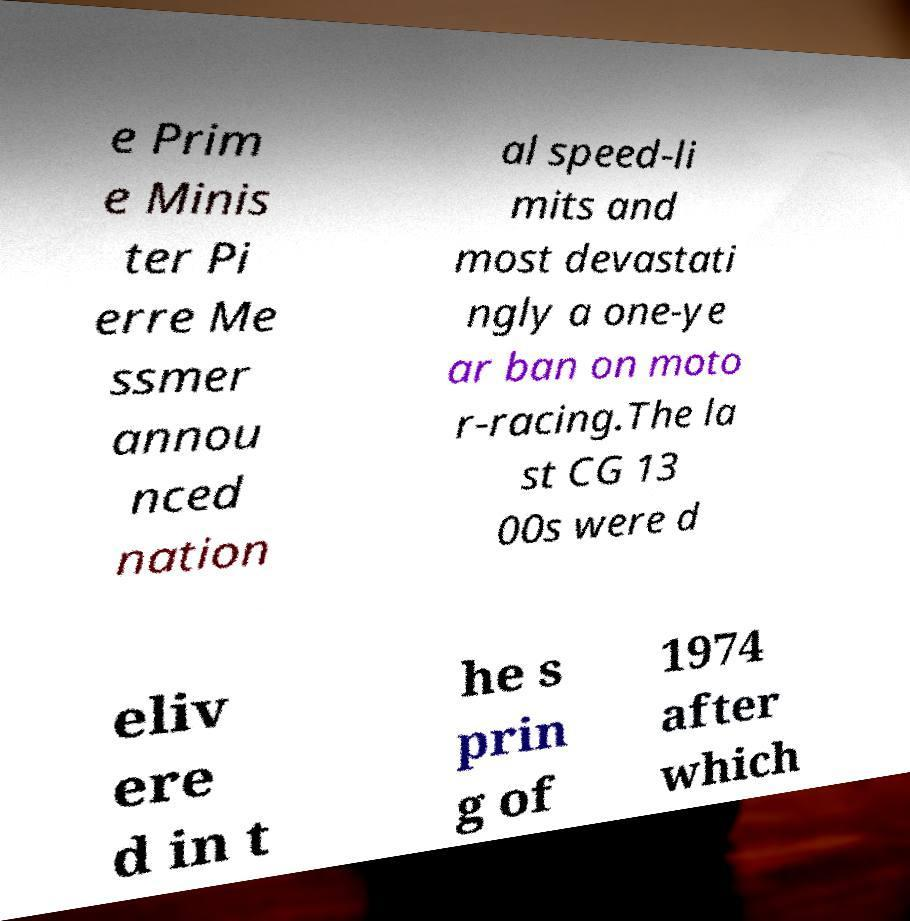There's text embedded in this image that I need extracted. Can you transcribe it verbatim? e Prim e Minis ter Pi erre Me ssmer annou nced nation al speed-li mits and most devastati ngly a one-ye ar ban on moto r-racing.The la st CG 13 00s were d eliv ere d in t he s prin g of 1974 after which 